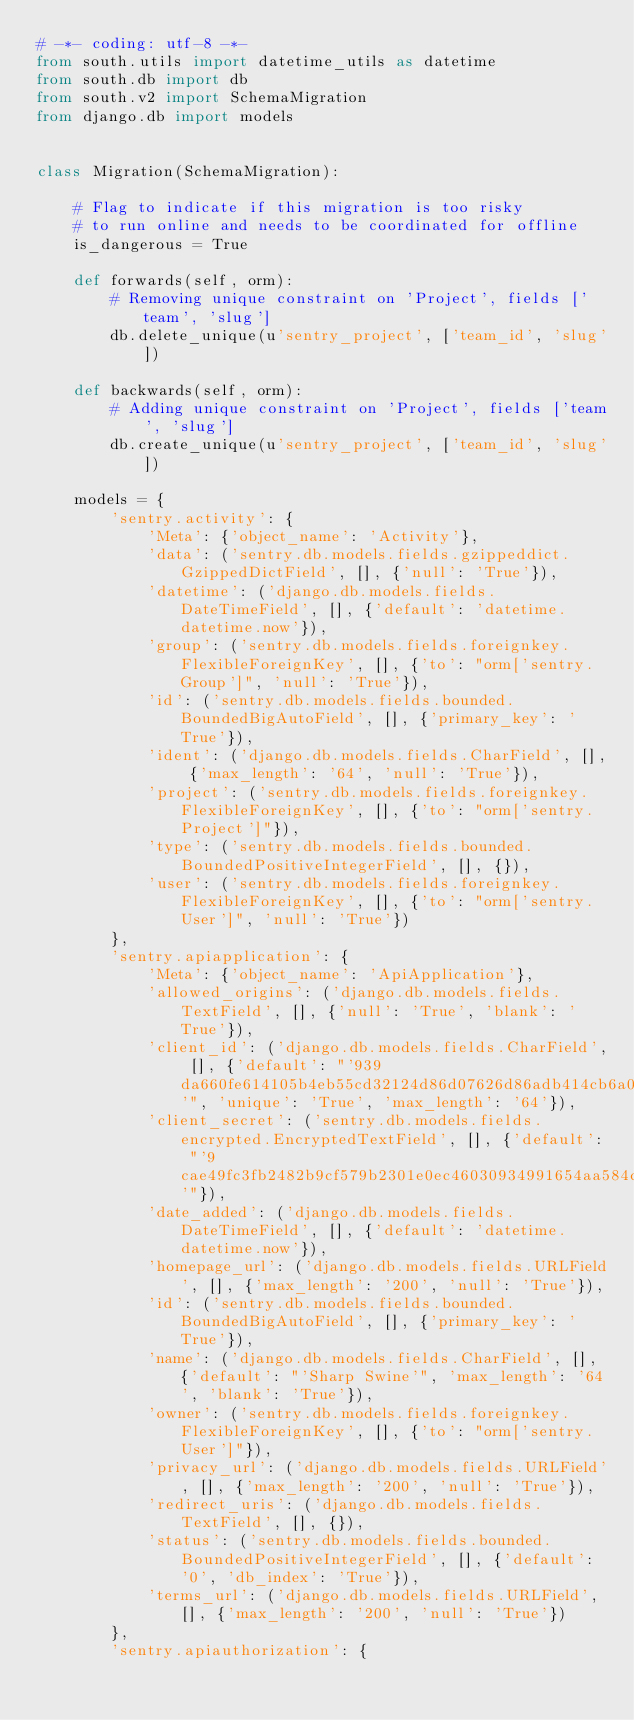<code> <loc_0><loc_0><loc_500><loc_500><_Python_># -*- coding: utf-8 -*-
from south.utils import datetime_utils as datetime
from south.db import db
from south.v2 import SchemaMigration
from django.db import models


class Migration(SchemaMigration):

    # Flag to indicate if this migration is too risky
    # to run online and needs to be coordinated for offline
    is_dangerous = True

    def forwards(self, orm):
        # Removing unique constraint on 'Project', fields ['team', 'slug']
        db.delete_unique(u'sentry_project', ['team_id', 'slug'])

    def backwards(self, orm):
        # Adding unique constraint on 'Project', fields ['team', 'slug']
        db.create_unique(u'sentry_project', ['team_id', 'slug'])

    models = {
        'sentry.activity': {
            'Meta': {'object_name': 'Activity'},
            'data': ('sentry.db.models.fields.gzippeddict.GzippedDictField', [], {'null': 'True'}),
            'datetime': ('django.db.models.fields.DateTimeField', [], {'default': 'datetime.datetime.now'}),
            'group': ('sentry.db.models.fields.foreignkey.FlexibleForeignKey', [], {'to': "orm['sentry.Group']", 'null': 'True'}),
            'id': ('sentry.db.models.fields.bounded.BoundedBigAutoField', [], {'primary_key': 'True'}),
            'ident': ('django.db.models.fields.CharField', [], {'max_length': '64', 'null': 'True'}),
            'project': ('sentry.db.models.fields.foreignkey.FlexibleForeignKey', [], {'to': "orm['sentry.Project']"}),
            'type': ('sentry.db.models.fields.bounded.BoundedPositiveIntegerField', [], {}),
            'user': ('sentry.db.models.fields.foreignkey.FlexibleForeignKey', [], {'to': "orm['sentry.User']", 'null': 'True'})
        },
        'sentry.apiapplication': {
            'Meta': {'object_name': 'ApiApplication'},
            'allowed_origins': ('django.db.models.fields.TextField', [], {'null': 'True', 'blank': 'True'}),
            'client_id': ('django.db.models.fields.CharField', [], {'default': "'939da660fe614105b4eb55cd32124d86d07626d86adb414cb6a02f21451afb37'", 'unique': 'True', 'max_length': '64'}),
            'client_secret': ('sentry.db.models.fields.encrypted.EncryptedTextField', [], {'default': "'9cae49fc3fb2482b9cf579b2301e0ec46030934991654aa584c16a2e8dcc66d3'"}),
            'date_added': ('django.db.models.fields.DateTimeField', [], {'default': 'datetime.datetime.now'}),
            'homepage_url': ('django.db.models.fields.URLField', [], {'max_length': '200', 'null': 'True'}),
            'id': ('sentry.db.models.fields.bounded.BoundedBigAutoField', [], {'primary_key': 'True'}),
            'name': ('django.db.models.fields.CharField', [], {'default': "'Sharp Swine'", 'max_length': '64', 'blank': 'True'}),
            'owner': ('sentry.db.models.fields.foreignkey.FlexibleForeignKey', [], {'to': "orm['sentry.User']"}),
            'privacy_url': ('django.db.models.fields.URLField', [], {'max_length': '200', 'null': 'True'}),
            'redirect_uris': ('django.db.models.fields.TextField', [], {}),
            'status': ('sentry.db.models.fields.bounded.BoundedPositiveIntegerField', [], {'default': '0', 'db_index': 'True'}),
            'terms_url': ('django.db.models.fields.URLField', [], {'max_length': '200', 'null': 'True'})
        },
        'sentry.apiauthorization': {</code> 